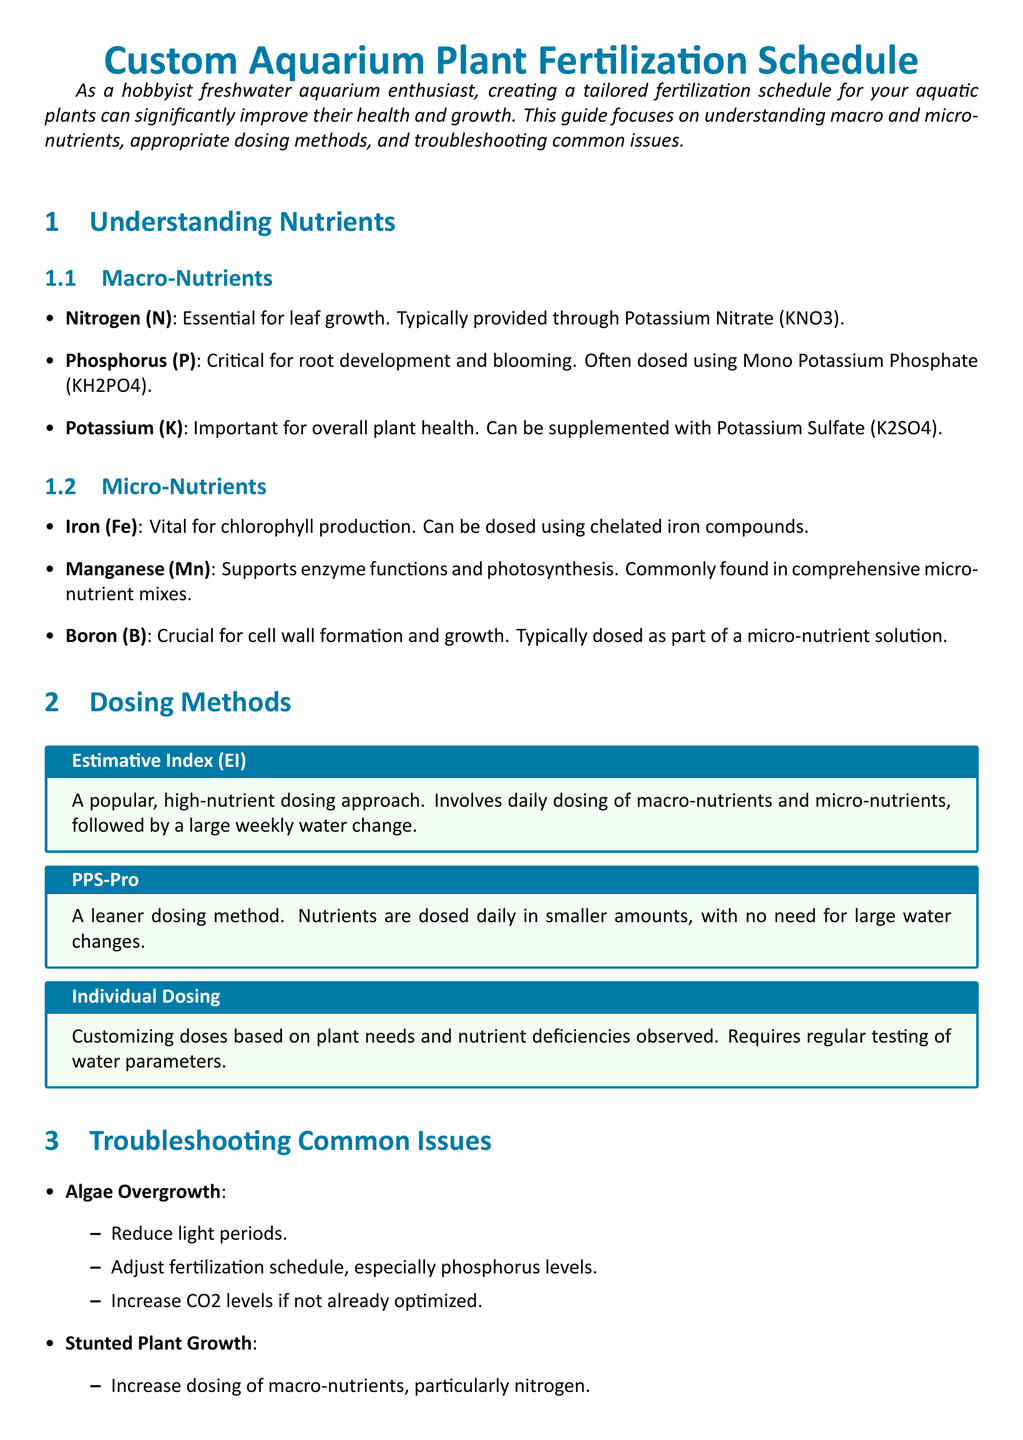What are the macro-nutrients? The document lists three macro-nutrients important for aquarium plants: Nitrogen, Phosphorus, and Potassium.
Answer: Nitrogen, Phosphorus, Potassium What method involves daily dosing and weekly water changes? The document describes the Estimative Index (EI) as a method that involves daily dosing of macro-nutrients and micro-nutrients followed by a large weekly water change.
Answer: Estimative Index Which micro-nutrient is vital for chlorophyll production? The document specifically states that Iron is vital for chlorophyll production among the micro-nutrients listed.
Answer: Iron What issue is caused by insufficient nitrogen? The document explains that stunted plant growth can occur due to insufficient nitrogen, among other causes.
Answer: Stunted Plant Growth How can algae overgrowth be reduced? According to the document, reducing light periods is one method to address algae overgrowth.
Answer: Reduce light periods What is the purpose of the troubleshooting section? The document's troubleshooting section aims to provide solutions for common plant health issues related to nutrient deficiencies and other factors.
Answer: Provide solutions for common issues What is the effect of increasing potassium dosing? The document states that increasing potassium dosing can help resolve yellowing leaves, among other issues.
Answer: Resolve yellowing leaves Which dosing method requires regular testing of water parameters? The document mentions that Individual Dosing involves customizing doses based on observed plant needs and requires regular testing of water parameters.
Answer: Individual Dosing 